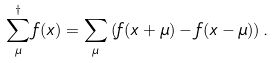<formula> <loc_0><loc_0><loc_500><loc_500>\sum _ { \mu } ^ { \dagger } f ( x ) = \sum _ { \mu } \left ( f ( x + \mu ) - f ( x - \mu ) \right ) .</formula> 